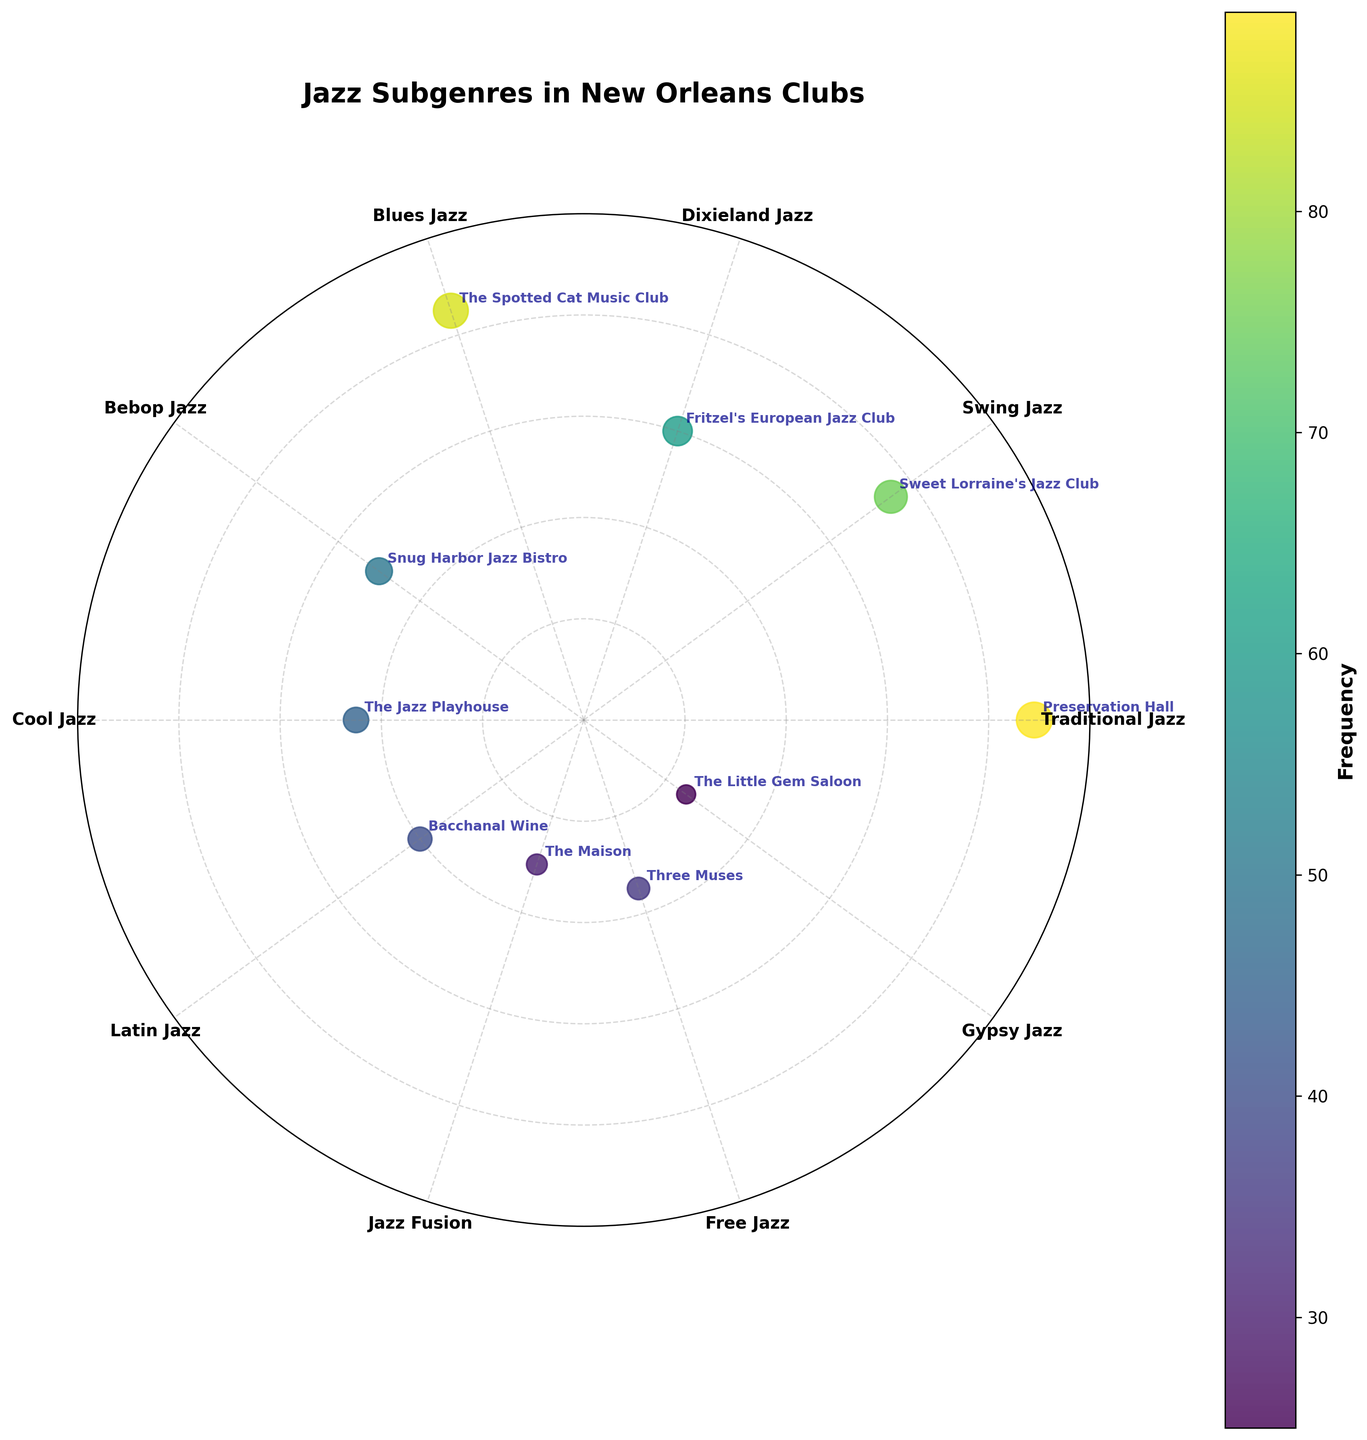what is the title of the figure? The title is written at the top of the plot. It reads "Jazz Subgenres in New Orleans Clubs".
Answer: Jazz Subgenres in New Orleans Clubs How many subgenres of jazz are represented in the plot? Count the number of labeled points on the plot, each representing a subgenre. There are ten subgenres listed.
Answer: 10 Which subgenre is played most frequently? Look for the largest radial distance (from the center outward) on the plot, which represents the frequency. The label "Traditional Jazz" is the farthest out.
Answer: Traditional Jazz Which club plays Cool Jazz, and how frequently? Find the point labeled "Cool Jazz" around the plot. The corresponding radial distance shows a frequency of 45, and the club name adjacent to it is "The Jazz Playhouse".
Answer: The Jazz Playhouse, 45 What is the average frequency of Bebop Jazz and Latin Jazz? Find the frequency values for Bebop Jazz (50) and Latin Jazz (40) and calculate their average: (50 + 40) / 2 = 45.
Answer: 45 What subgenre has a frequency closest to 50? Look for the data points with frequencies marked around 50. Bebop Jazz has a frequency exactly equal to 50.
Answer: Bebop Jazz Which subgenre is played least frequently? Identify the point closest to the center, indicating the lowest frequency. The point for Gypsy Jazz is closest with a value of 25.
Answer: Gypsy Jazz Compare the frequencies of Swing Jazz and Free Jazz. Which is more frequent, and by how much? Find the frequencies for Swing Jazz (75) and Free Jazz (35). Subtract to find the difference: 75 - 35 = 40. Thus, Swing Jazz is more frequent by 40.
Answer: Swing Jazz by 40 What is the median frequency of the subgenres? List the frequencies in ascending order: 25, 30, 35, 40, 45, 50, 60, 75, 85, 89. The median is the middle value when the numbers are in order. With 10 values, the median is the average of the 5th and 6th values: (45+50)/2 = 47.5.
Answer: 47.5 Which club features the second most frequent subgenre, and what is that subgenre? Identify the subgenre with the second highest radial distance from the center. Blues Jazz is the second farthest, played by "The Spotted Cat Music Club".
Answer: The Spotted Cat Music Club, Blues Jazz 